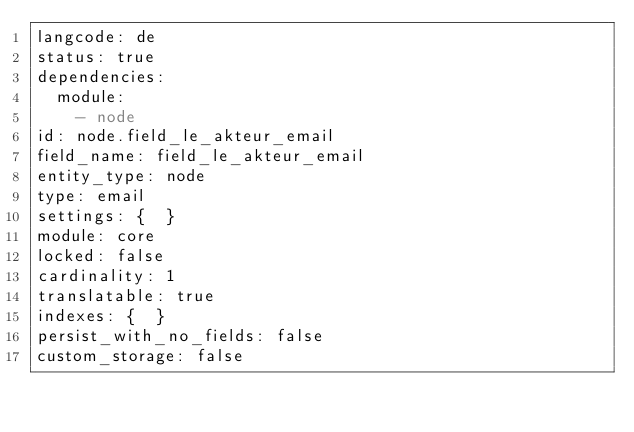<code> <loc_0><loc_0><loc_500><loc_500><_YAML_>langcode: de
status: true
dependencies:
  module:
    - node
id: node.field_le_akteur_email
field_name: field_le_akteur_email
entity_type: node
type: email
settings: {  }
module: core
locked: false
cardinality: 1
translatable: true
indexes: {  }
persist_with_no_fields: false
custom_storage: false
</code> 